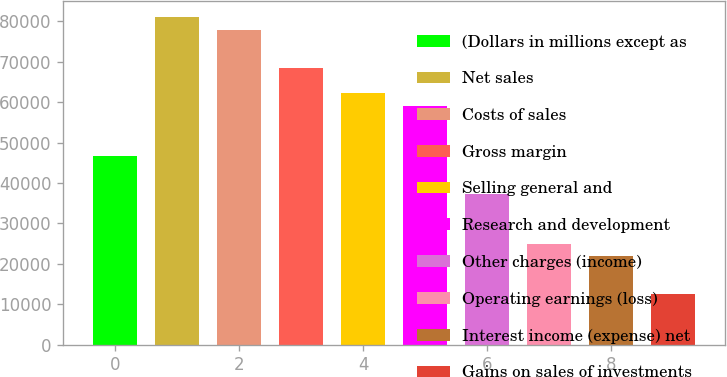Convert chart. <chart><loc_0><loc_0><loc_500><loc_500><bar_chart><fcel>(Dollars in millions except as<fcel>Net sales<fcel>Costs of sales<fcel>Gross margin<fcel>Selling general and<fcel>Research and development<fcel>Other charges (income)<fcel>Operating earnings (loss)<fcel>Interest income (expense) net<fcel>Gains on sales of investments<nl><fcel>46727.9<fcel>80994.8<fcel>77879.7<fcel>68534.1<fcel>62303.8<fcel>59188.6<fcel>37382.3<fcel>24921.6<fcel>21806.4<fcel>12460.9<nl></chart> 